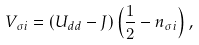<formula> <loc_0><loc_0><loc_500><loc_500>V _ { \sigma i } = ( U _ { d d } - J ) \left ( \frac { 1 } { 2 } - n _ { \sigma i } \right ) ,</formula> 